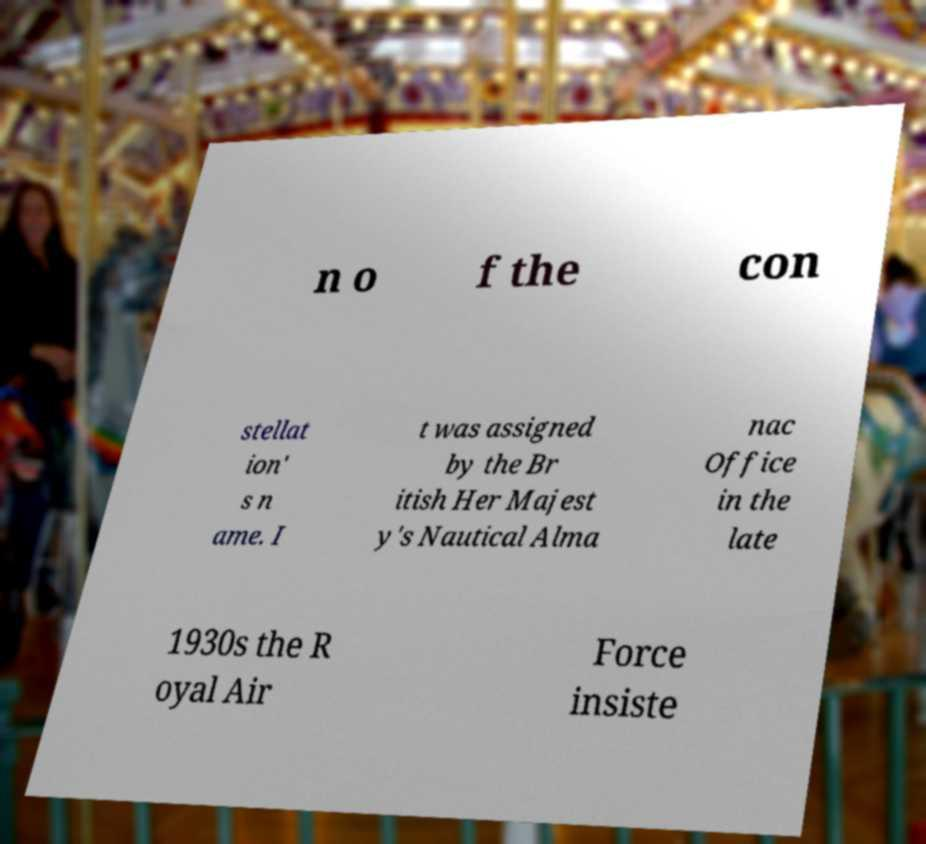Could you assist in decoding the text presented in this image and type it out clearly? n o f the con stellat ion' s n ame. I t was assigned by the Br itish Her Majest y's Nautical Alma nac Office in the late 1930s the R oyal Air Force insiste 